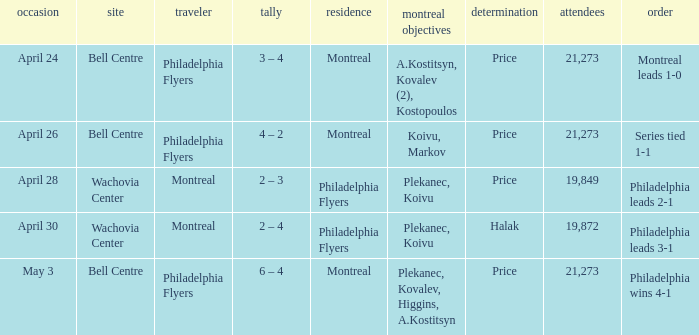What was the average attendance when the decision was price and montreal were the visitors? 19849.0. 